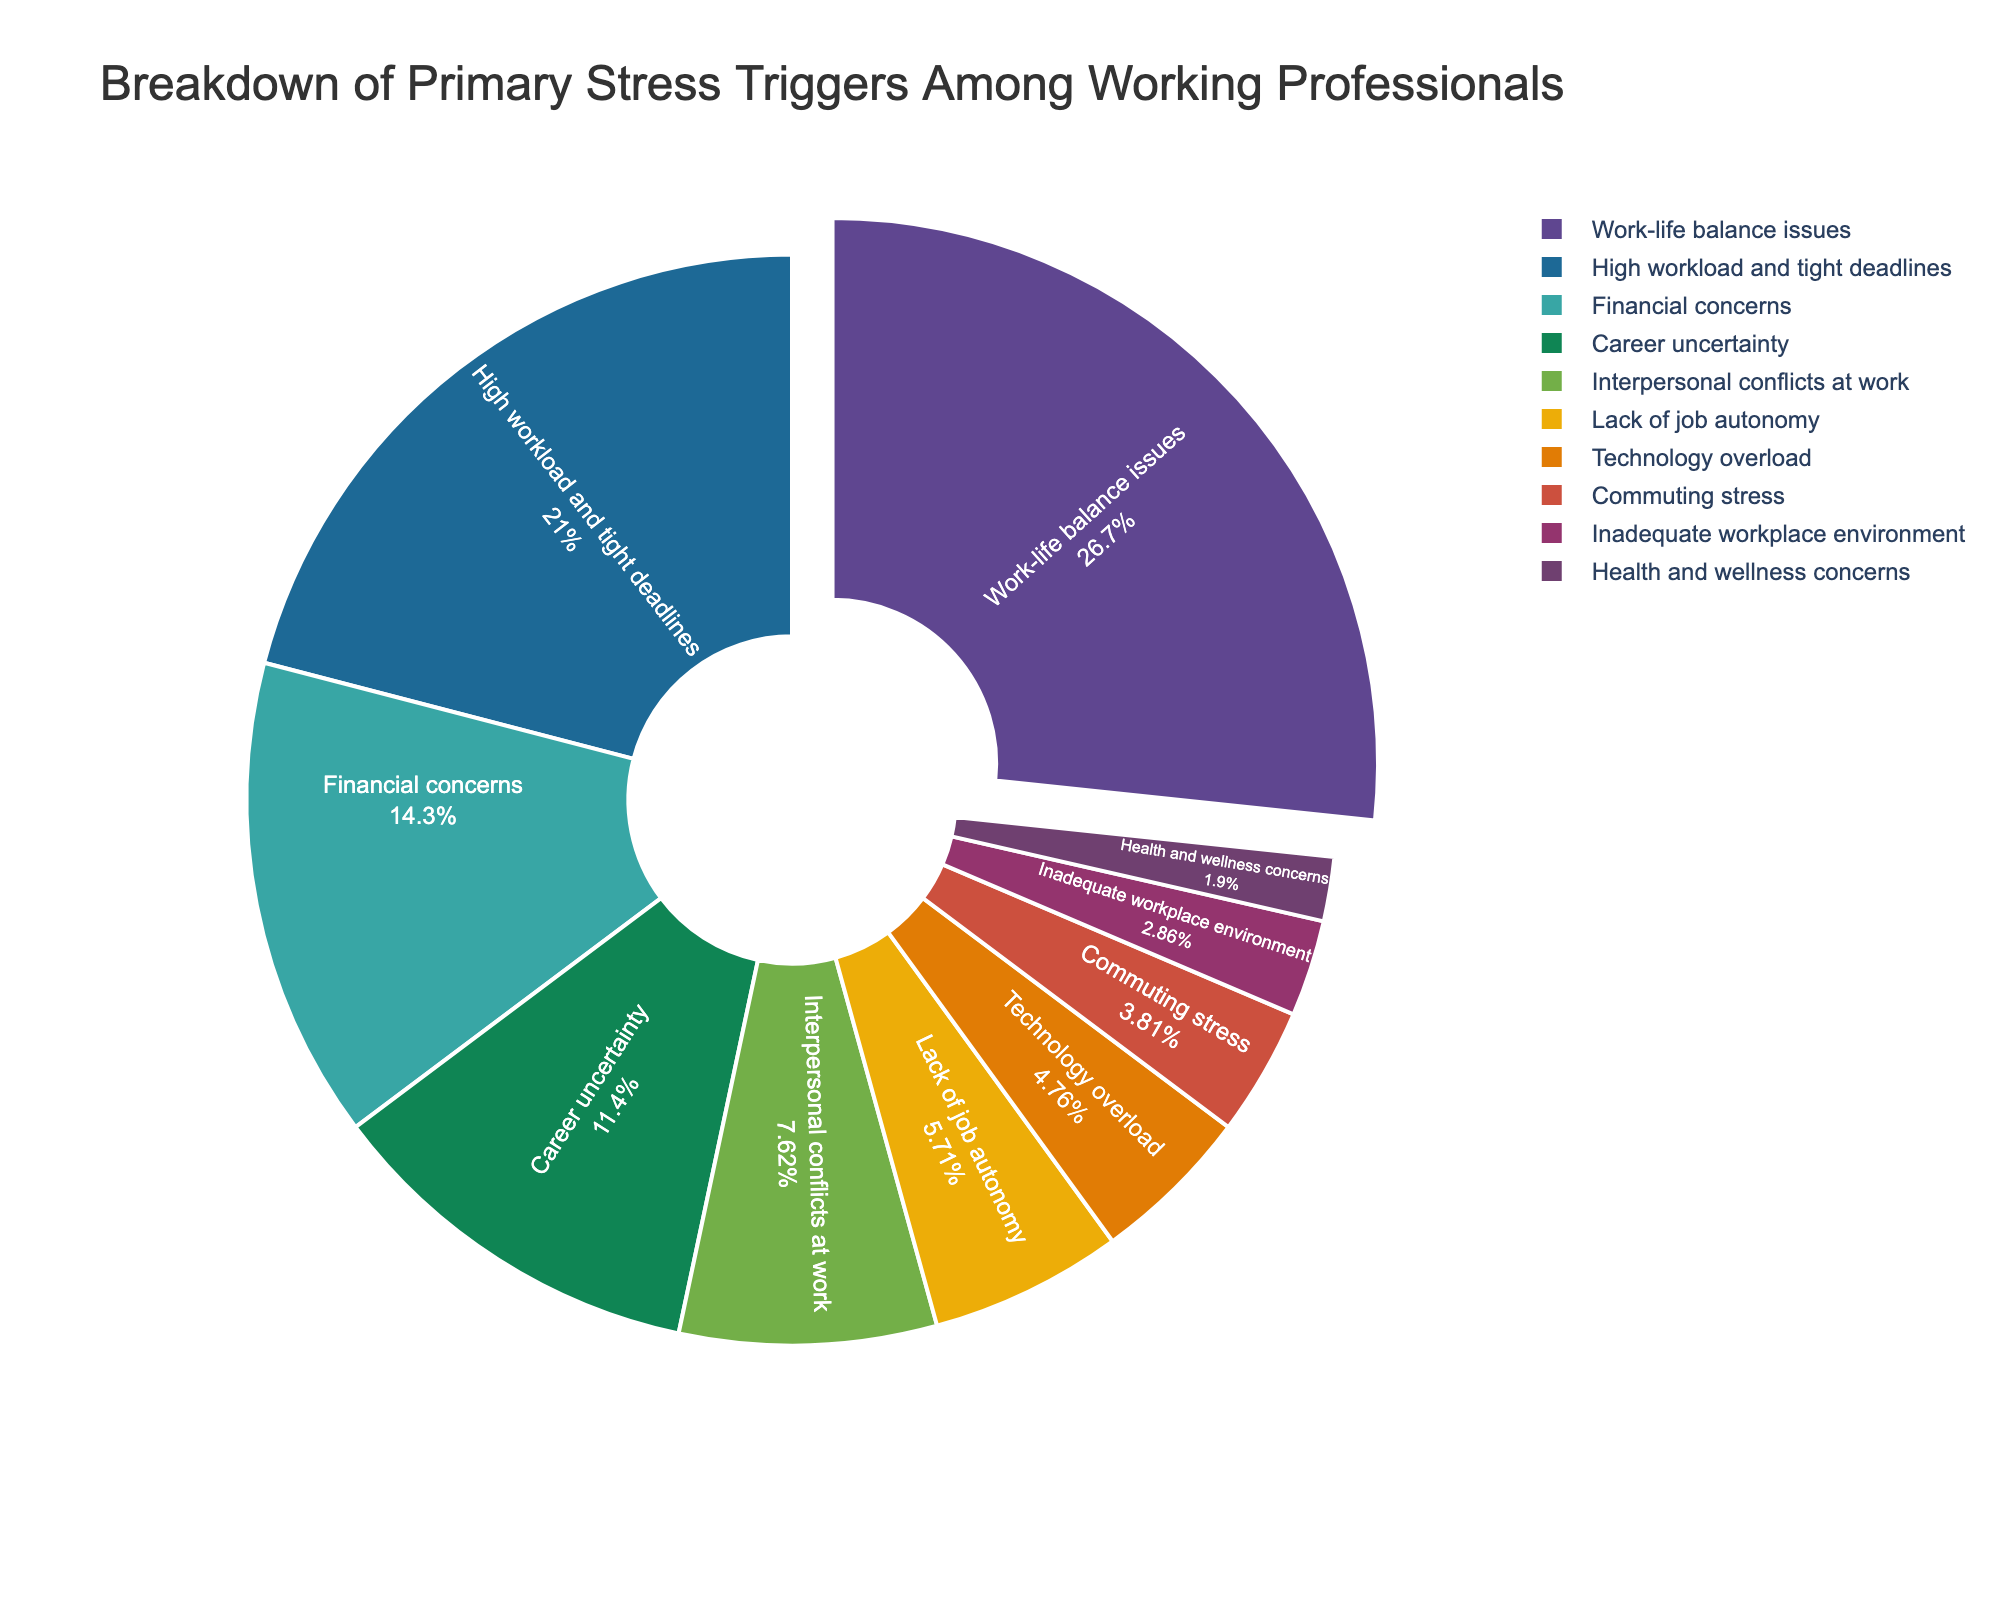Which stress trigger has the highest percentage? Looking at the pie chart, the segment with the highest percentage is labeled "Work-life balance issues." It is the largest slice in the pie chart.
Answer: Work-life balance issues What is the total percentage for 'High workload and tight deadlines' and 'Financial concerns'? The pie chart shows that 'High workload and tight deadlines' has a percentage of 22% and 'Financial concerns' has a percentage of 15%. Adding these together, we get 22% + 15% = 37%.
Answer: 37% Which stress trigger is represented by the smallest segment in the pie chart? By examining the pie chart, the smallest segment corresponds to 'Health and wellness concerns' which is labeled as 2%.
Answer: Health and wellness concerns Is 'Career uncertainty' a more significant stress trigger than 'Interpersonal conflicts at work'? The pie chart indicates that 'Career uncertainty' has a percentage of 12%, while 'Interpersonal conflicts at work' has 8%. Since 12% is greater than 8%, 'Career uncertainty' is indeed a more significant stress trigger.
Answer: Yes How does the percentage of 'Technology overload' compare to that of 'Commuting stress'? The pie chart shows 'Technology overload' has a percentage of 5% and 'Commuting stress' has 4%. Since 5% is greater than 4%, 'Technology overload' has a higher percentage.
Answer: Technology overload has a higher percentage What is the combined percentage of all stress triggers related to the workplace environment (consider 'Inadequate workplace environment' and 'Lack of job autonomy')? According to the pie chart, 'Inadequate workplace environment' has a percentage of 3% and 'Lack of job autonomy' has 6%. Adding these together, we get 3% + 6% = 9%.
Answer: 9% What is the percentage difference between 'Work-life balance issues' and 'Career uncertainty'? The pie chart shows 'Work-life balance issues' at 28% and 'Career uncertainty' at 12%. The difference is 28% - 12% = 16%.
Answer: 16% Which stress triggers have a percentage that is less than 10%? By looking at the pie chart, the stress triggers with percentages less than 10% are 'Interpersonal conflicts at work' (8%), 'Lack of job autonomy' (6%), 'Technology overload' (5%), 'Commuting stress' (4%), 'Inadequate workplace environment' (3%), 'Health and wellness concerns' (2%).
Answer: Interpersonal conflicts at work, Lack of job autonomy, Technology overload, Commuting stress, Inadequate workplace environment, Health and wellness concerns What visual feature in the pie chart makes it easy to identify the most significant stress trigger? The pie chart uses size to differentiate between segments, and 'Work-life balance issues' is the largest segment. Additionally, this segment is slightly pulled out from the pie, making it visually distinctive as the most significant stress trigger.
Answer: Largest segment, pulled out Are there more stress triggers with percentages greater than or equal to 6% or less than 6%? According to the pie chart, stress triggers with percentages greater than or equal to 6% are 6: 'Work-life balance issues', 'High workload and tight deadlines', 'Financial concerns', 'Career uncertainty', 'Interpersonal conflicts at work', 'Lack of job autonomy'. Those less than 6% are 4: 'Technology overload', 'Commuting stress', 'Inadequate workplace environment', 'Health and wellness concerns'. There are more stress triggers with percentages greater than or equal to 6%.
Answer: Greater than or equal to 6% 